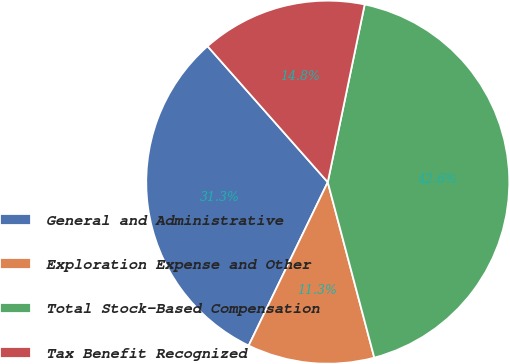<chart> <loc_0><loc_0><loc_500><loc_500><pie_chart><fcel>General and Administrative<fcel>Exploration Expense and Other<fcel>Total Stock-Based Compensation<fcel>Tax Benefit Recognized<nl><fcel>31.3%<fcel>11.3%<fcel>42.61%<fcel>14.78%<nl></chart> 